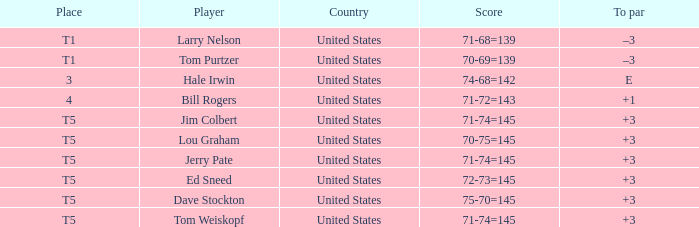Who is the player with a t5 place and a 75-70=145 score? Dave Stockton. 